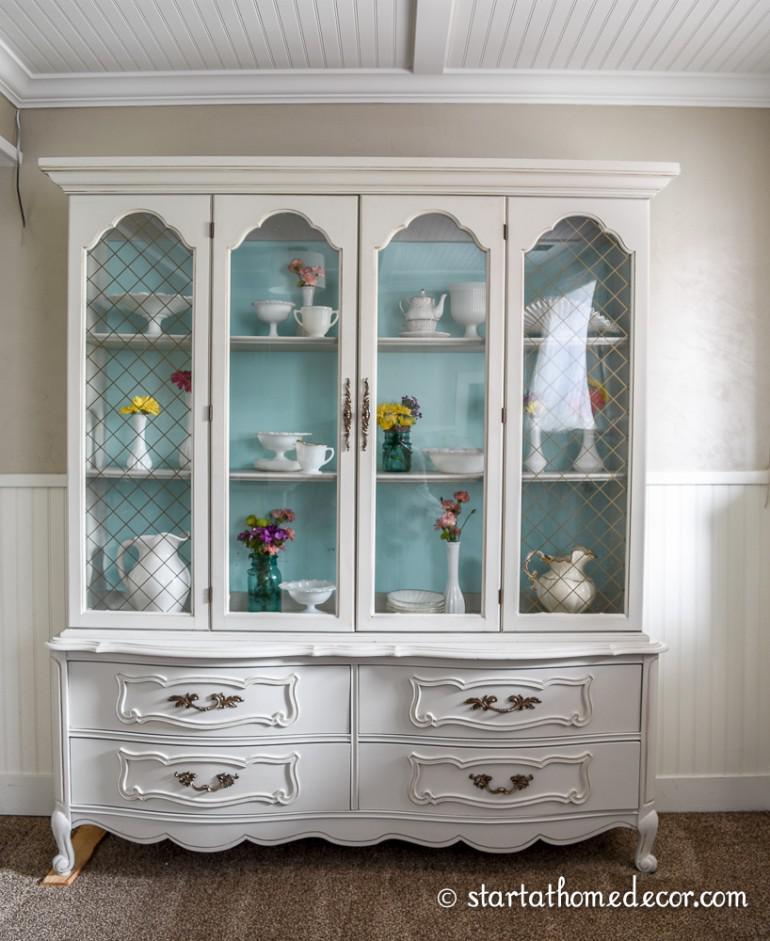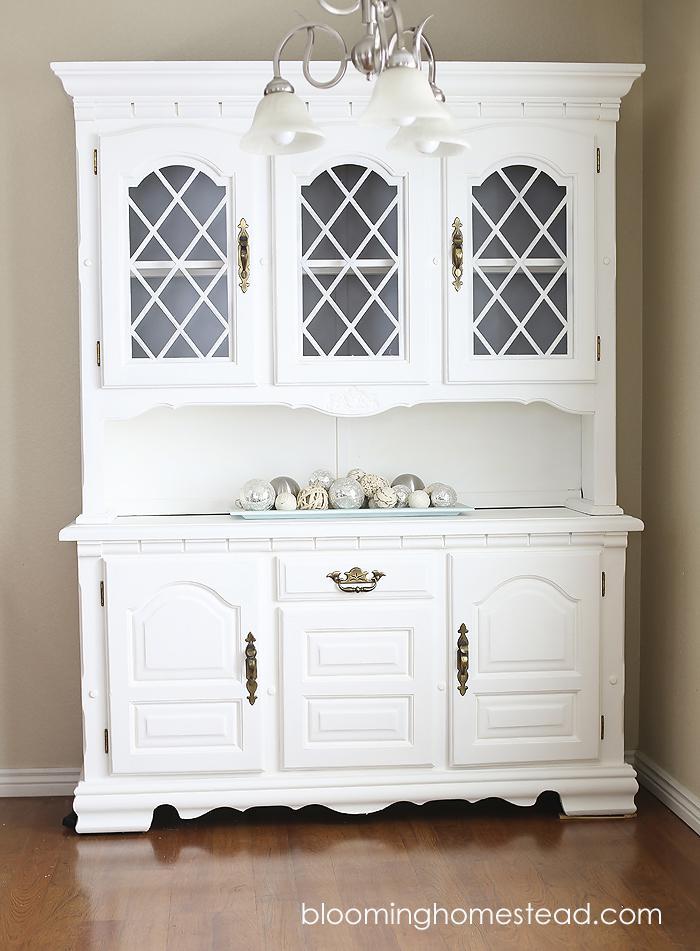The first image is the image on the left, the second image is the image on the right. Analyze the images presented: Is the assertion "At least one cabinet has a non-flat top with nothing perched above it, and a bottom that lacks any scrollwork." valid? Answer yes or no. No. 